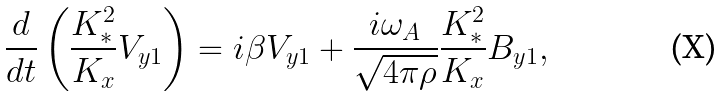<formula> <loc_0><loc_0><loc_500><loc_500>\frac { d } { d t } \left ( \frac { K ^ { 2 } _ { * } } { K _ { x } } V _ { y 1 } \right ) = i \beta V _ { y 1 } + \frac { i \omega _ { A } } { \sqrt { 4 \pi \rho } } \frac { K ^ { 2 } _ { * } } { K _ { x } } B _ { y 1 } ,</formula> 